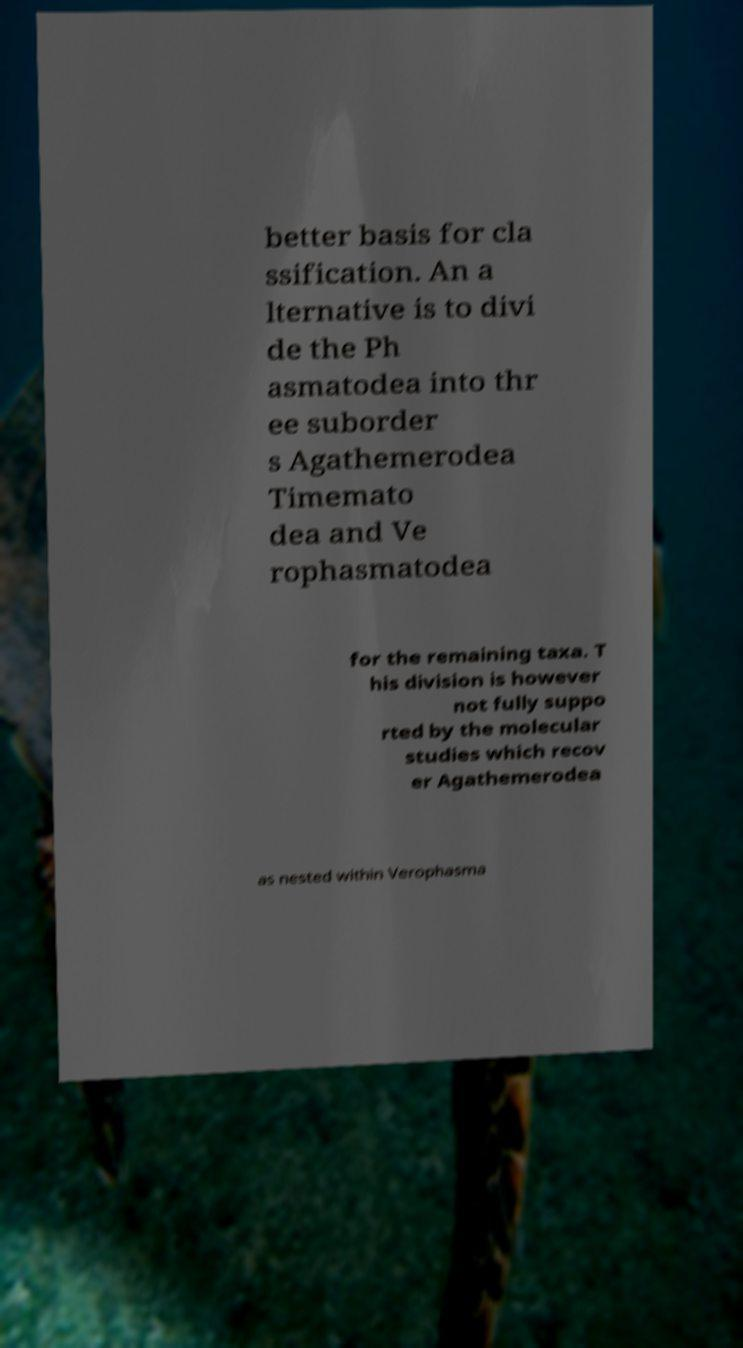Please read and relay the text visible in this image. What does it say? better basis for cla ssification. An a lternative is to divi de the Ph asmatodea into thr ee suborder s Agathemerodea Timemato dea and Ve rophasmatodea for the remaining taxa. T his division is however not fully suppo rted by the molecular studies which recov er Agathemerodea as nested within Verophasma 